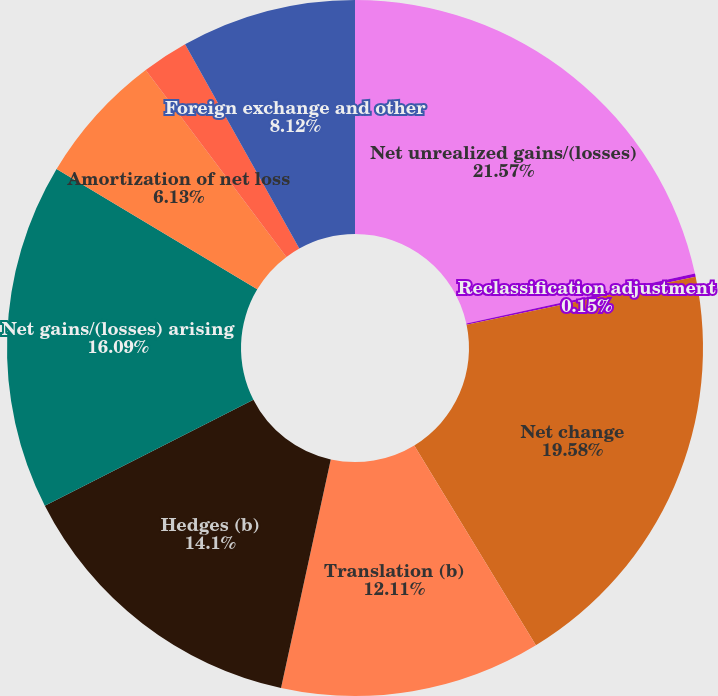Convert chart. <chart><loc_0><loc_0><loc_500><loc_500><pie_chart><fcel>Net unrealized gains/(losses)<fcel>Reclassification adjustment<fcel>Net change<fcel>Translation (b)<fcel>Hedges (b)<fcel>Net gains/(losses) arising<fcel>Amortization of net loss<fcel>Prior service costs/(credits)<fcel>Foreign exchange and other<nl><fcel>21.57%<fcel>0.15%<fcel>19.58%<fcel>12.11%<fcel>14.1%<fcel>16.09%<fcel>6.13%<fcel>2.15%<fcel>8.12%<nl></chart> 